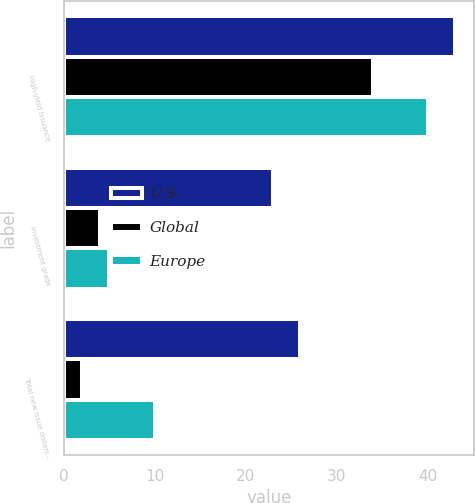Convert chart. <chart><loc_0><loc_0><loc_500><loc_500><stacked_bar_chart><ecel><fcel>High-yield issuance<fcel>Investment grade<fcel>Total new issue dollars -<nl><fcel>U.S.<fcel>43<fcel>23<fcel>26<nl><fcel>Global<fcel>34<fcel>4<fcel>2<nl><fcel>Europe<fcel>40<fcel>5<fcel>10<nl></chart> 